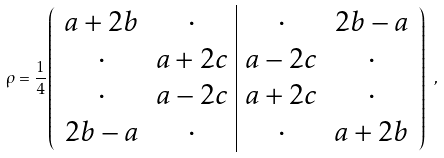Convert formula to latex. <formula><loc_0><loc_0><loc_500><loc_500>\rho = \frac { 1 } { 4 } \left ( \begin{array} { c c | c c } a + 2 b & \cdot & \cdot & 2 b - a \\ \cdot & a + 2 c & a - 2 c & \cdot \\ \cdot & a - 2 c & a + 2 c & \cdot \\ 2 b - a & \cdot & \cdot & a + 2 b \end{array} \right ) \ ,</formula> 